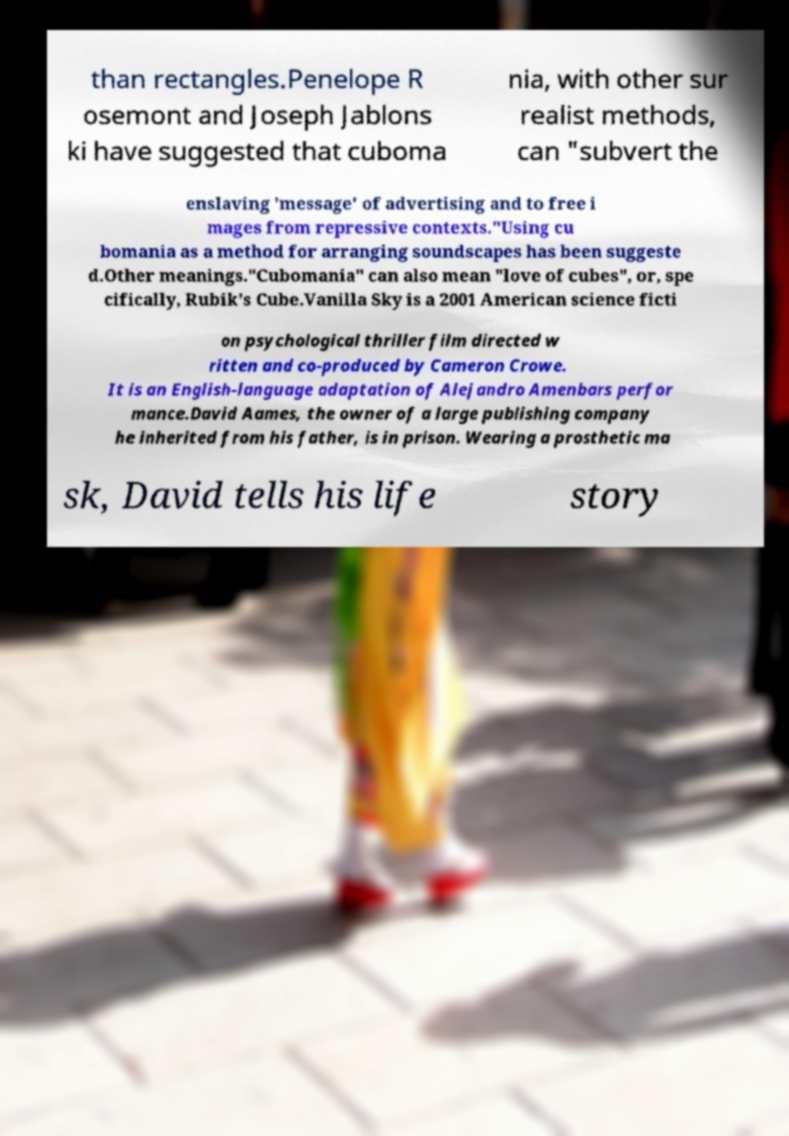Could you extract and type out the text from this image? than rectangles.Penelope R osemont and Joseph Jablons ki have suggested that cuboma nia, with other sur realist methods, can "subvert the enslaving 'message' of advertising and to free i mages from repressive contexts."Using cu bomania as a method for arranging soundscapes has been suggeste d.Other meanings."Cubomania" can also mean "love of cubes", or, spe cifically, Rubik's Cube.Vanilla Sky is a 2001 American science ficti on psychological thriller film directed w ritten and co-produced by Cameron Crowe. It is an English-language adaptation of Alejandro Amenbars perfor mance.David Aames, the owner of a large publishing company he inherited from his father, is in prison. Wearing a prosthetic ma sk, David tells his life story 